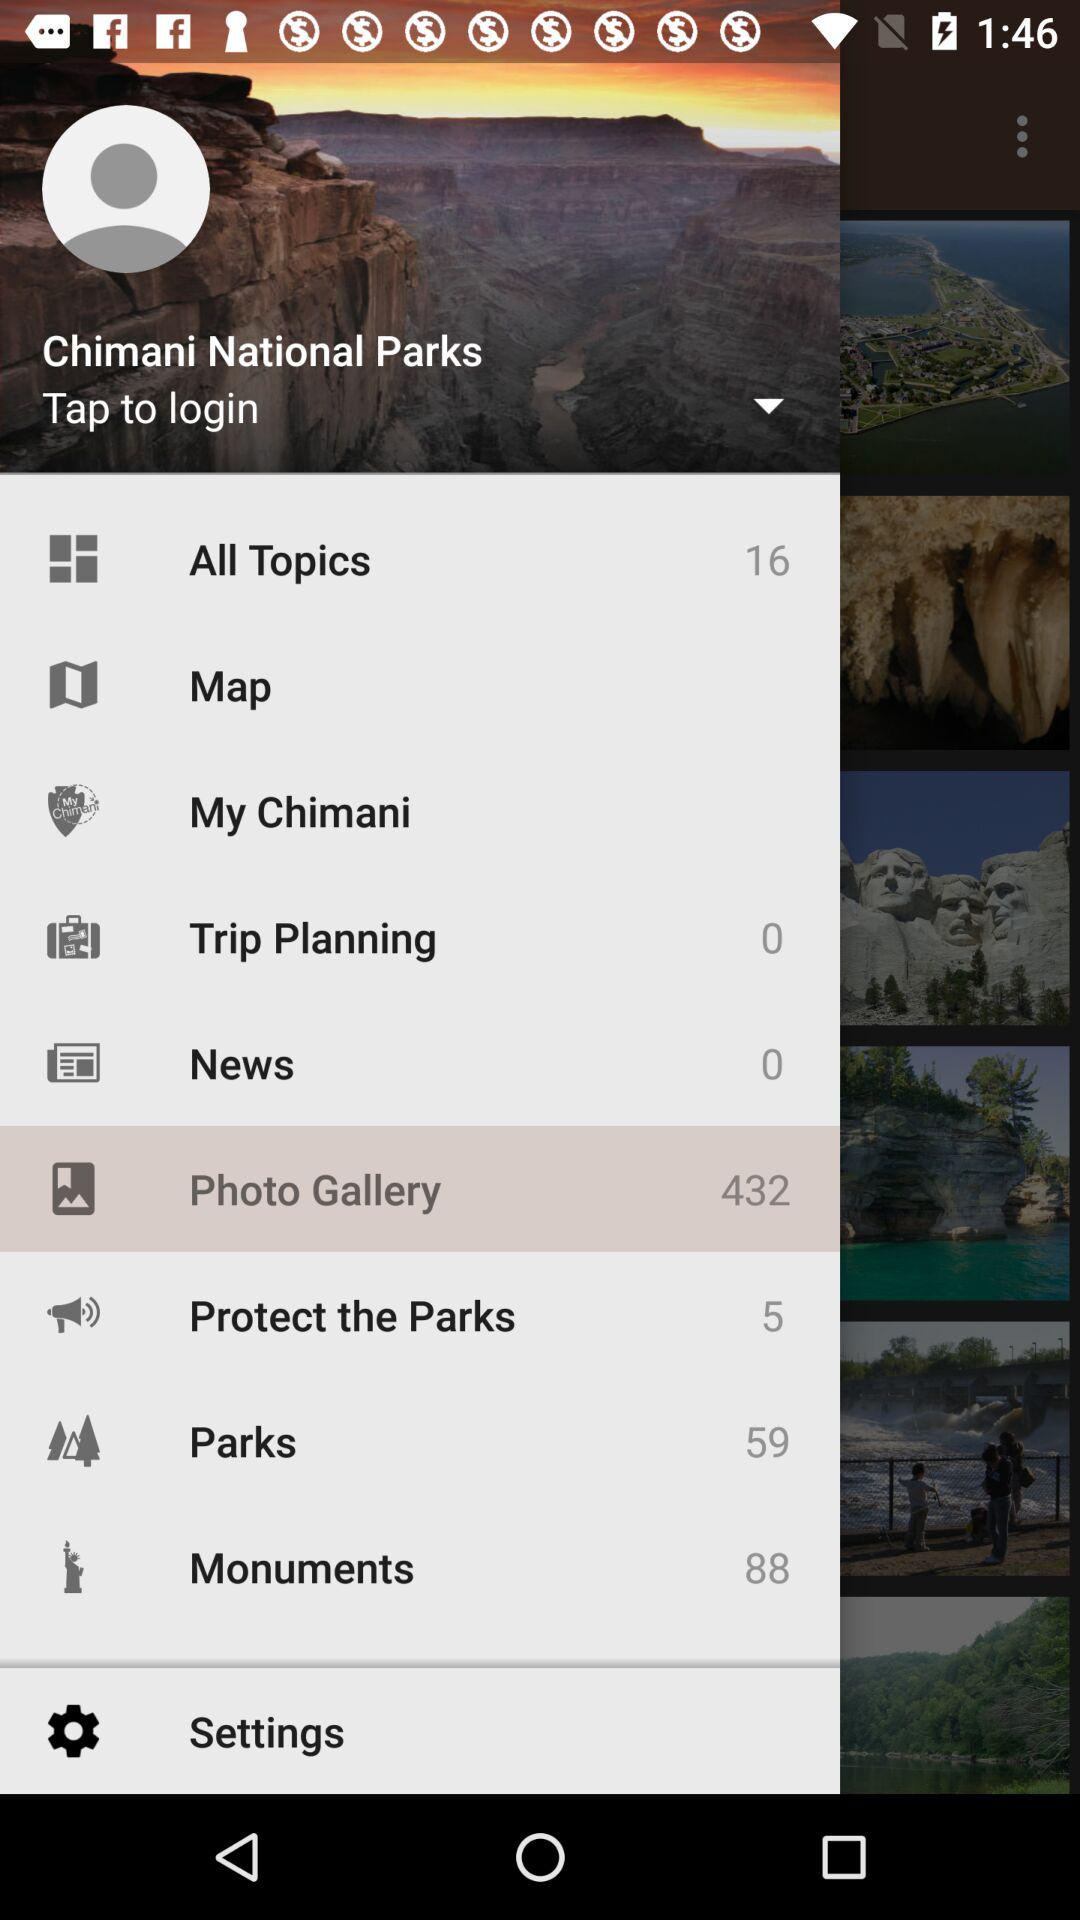What is the number of parks? The number of parks is 59. 